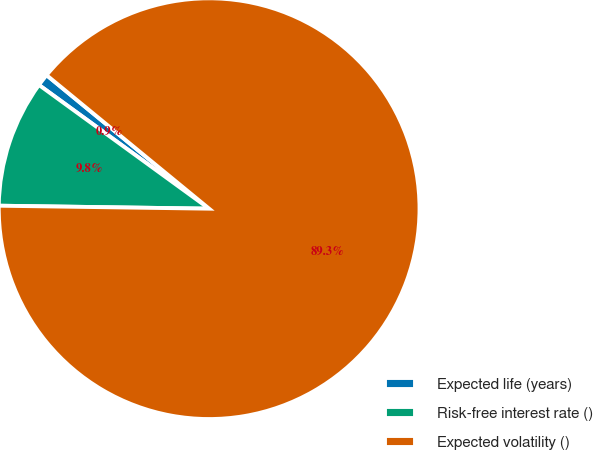<chart> <loc_0><loc_0><loc_500><loc_500><pie_chart><fcel>Expected life (years)<fcel>Risk-free interest rate ()<fcel>Expected volatility ()<nl><fcel>0.94%<fcel>9.78%<fcel>89.28%<nl></chart> 